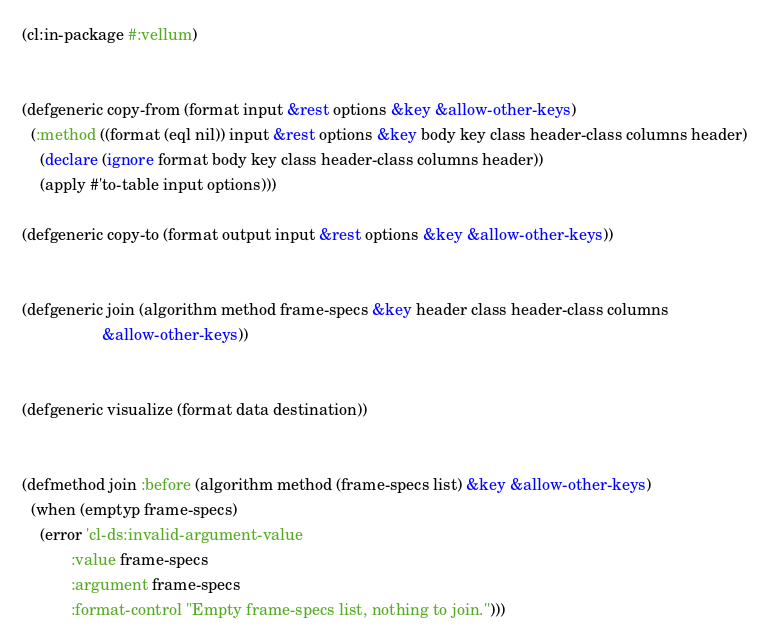Convert code to text. <code><loc_0><loc_0><loc_500><loc_500><_Lisp_>(cl:in-package #:vellum)


(defgeneric copy-from (format input &rest options &key &allow-other-keys)
  (:method ((format (eql nil)) input &rest options &key body key class header-class columns header)
    (declare (ignore format body key class header-class columns header))
    (apply #'to-table input options)))

(defgeneric copy-to (format output input &rest options &key &allow-other-keys))


(defgeneric join (algorithm method frame-specs &key header class header-class columns
                  &allow-other-keys))


(defgeneric visualize (format data destination))


(defmethod join :before (algorithm method (frame-specs list) &key &allow-other-keys)
  (when (emptyp frame-specs)
    (error 'cl-ds:invalid-argument-value
           :value frame-specs
           :argument frame-specs
           :format-control "Empty frame-specs list, nothing to join.")))
</code> 